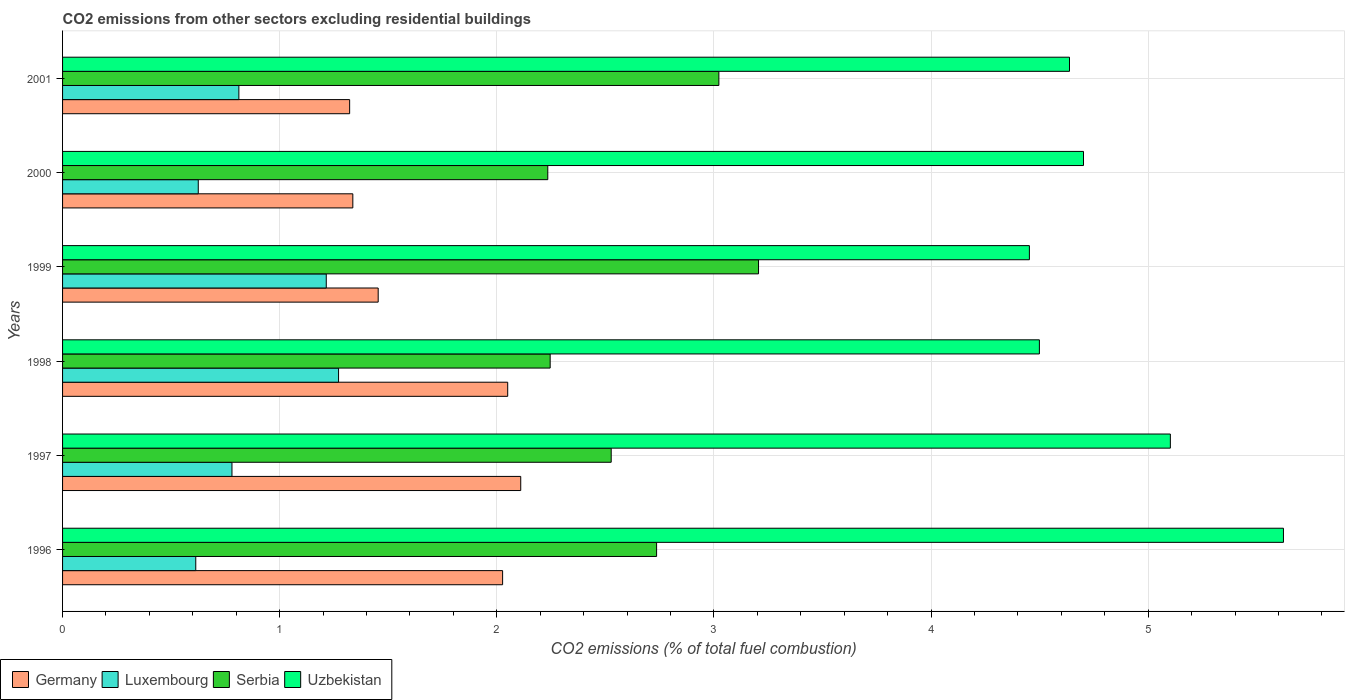How many different coloured bars are there?
Provide a succinct answer. 4. What is the label of the 5th group of bars from the top?
Offer a terse response. 1997. What is the total CO2 emitted in Luxembourg in 1999?
Your answer should be very brief. 1.21. Across all years, what is the maximum total CO2 emitted in Luxembourg?
Offer a very short reply. 1.27. Across all years, what is the minimum total CO2 emitted in Luxembourg?
Make the answer very short. 0.61. In which year was the total CO2 emitted in Uzbekistan minimum?
Keep it short and to the point. 1999. What is the total total CO2 emitted in Serbia in the graph?
Make the answer very short. 15.97. What is the difference between the total CO2 emitted in Serbia in 1999 and that in 2000?
Make the answer very short. 0.97. What is the difference between the total CO2 emitted in Germany in 2001 and the total CO2 emitted in Serbia in 1999?
Provide a short and direct response. -1.88. What is the average total CO2 emitted in Germany per year?
Ensure brevity in your answer.  1.72. In the year 1999, what is the difference between the total CO2 emitted in Germany and total CO2 emitted in Serbia?
Provide a short and direct response. -1.75. In how many years, is the total CO2 emitted in Serbia greater than 4.8 ?
Offer a very short reply. 0. What is the ratio of the total CO2 emitted in Germany in 1996 to that in 1998?
Offer a very short reply. 0.99. Is the total CO2 emitted in Serbia in 1997 less than that in 1998?
Your response must be concise. No. What is the difference between the highest and the second highest total CO2 emitted in Germany?
Provide a succinct answer. 0.06. What is the difference between the highest and the lowest total CO2 emitted in Uzbekistan?
Offer a terse response. 1.17. In how many years, is the total CO2 emitted in Germany greater than the average total CO2 emitted in Germany taken over all years?
Provide a succinct answer. 3. What does the 1st bar from the top in 2001 represents?
Offer a very short reply. Uzbekistan. What does the 1st bar from the bottom in 2001 represents?
Ensure brevity in your answer.  Germany. Is it the case that in every year, the sum of the total CO2 emitted in Germany and total CO2 emitted in Uzbekistan is greater than the total CO2 emitted in Serbia?
Make the answer very short. Yes. How many bars are there?
Provide a short and direct response. 24. How many years are there in the graph?
Your answer should be very brief. 6. Does the graph contain any zero values?
Provide a short and direct response. No. Does the graph contain grids?
Keep it short and to the point. Yes. Where does the legend appear in the graph?
Make the answer very short. Bottom left. How many legend labels are there?
Your answer should be very brief. 4. How are the legend labels stacked?
Your answer should be very brief. Horizontal. What is the title of the graph?
Offer a terse response. CO2 emissions from other sectors excluding residential buildings. What is the label or title of the X-axis?
Make the answer very short. CO2 emissions (% of total fuel combustion). What is the CO2 emissions (% of total fuel combustion) of Germany in 1996?
Make the answer very short. 2.03. What is the CO2 emissions (% of total fuel combustion) in Luxembourg in 1996?
Your answer should be very brief. 0.61. What is the CO2 emissions (% of total fuel combustion) in Serbia in 1996?
Ensure brevity in your answer.  2.74. What is the CO2 emissions (% of total fuel combustion) of Uzbekistan in 1996?
Your response must be concise. 5.62. What is the CO2 emissions (% of total fuel combustion) of Germany in 1997?
Your response must be concise. 2.11. What is the CO2 emissions (% of total fuel combustion) in Luxembourg in 1997?
Your answer should be compact. 0.78. What is the CO2 emissions (% of total fuel combustion) of Serbia in 1997?
Give a very brief answer. 2.53. What is the CO2 emissions (% of total fuel combustion) of Uzbekistan in 1997?
Make the answer very short. 5.1. What is the CO2 emissions (% of total fuel combustion) in Germany in 1998?
Keep it short and to the point. 2.05. What is the CO2 emissions (% of total fuel combustion) of Luxembourg in 1998?
Your answer should be very brief. 1.27. What is the CO2 emissions (% of total fuel combustion) of Serbia in 1998?
Provide a succinct answer. 2.25. What is the CO2 emissions (% of total fuel combustion) of Uzbekistan in 1998?
Your answer should be compact. 4.5. What is the CO2 emissions (% of total fuel combustion) in Germany in 1999?
Your answer should be very brief. 1.45. What is the CO2 emissions (% of total fuel combustion) in Luxembourg in 1999?
Keep it short and to the point. 1.21. What is the CO2 emissions (% of total fuel combustion) of Serbia in 1999?
Offer a very short reply. 3.21. What is the CO2 emissions (% of total fuel combustion) of Uzbekistan in 1999?
Keep it short and to the point. 4.45. What is the CO2 emissions (% of total fuel combustion) in Germany in 2000?
Give a very brief answer. 1.34. What is the CO2 emissions (% of total fuel combustion) of Luxembourg in 2000?
Keep it short and to the point. 0.62. What is the CO2 emissions (% of total fuel combustion) of Serbia in 2000?
Give a very brief answer. 2.23. What is the CO2 emissions (% of total fuel combustion) in Uzbekistan in 2000?
Provide a succinct answer. 4.7. What is the CO2 emissions (% of total fuel combustion) in Germany in 2001?
Offer a very short reply. 1.32. What is the CO2 emissions (% of total fuel combustion) in Luxembourg in 2001?
Offer a terse response. 0.81. What is the CO2 emissions (% of total fuel combustion) in Serbia in 2001?
Keep it short and to the point. 3.02. What is the CO2 emissions (% of total fuel combustion) of Uzbekistan in 2001?
Provide a succinct answer. 4.64. Across all years, what is the maximum CO2 emissions (% of total fuel combustion) in Germany?
Keep it short and to the point. 2.11. Across all years, what is the maximum CO2 emissions (% of total fuel combustion) in Luxembourg?
Ensure brevity in your answer.  1.27. Across all years, what is the maximum CO2 emissions (% of total fuel combustion) of Serbia?
Ensure brevity in your answer.  3.21. Across all years, what is the maximum CO2 emissions (% of total fuel combustion) of Uzbekistan?
Make the answer very short. 5.62. Across all years, what is the minimum CO2 emissions (% of total fuel combustion) of Germany?
Provide a short and direct response. 1.32. Across all years, what is the minimum CO2 emissions (% of total fuel combustion) in Luxembourg?
Keep it short and to the point. 0.61. Across all years, what is the minimum CO2 emissions (% of total fuel combustion) of Serbia?
Your response must be concise. 2.23. Across all years, what is the minimum CO2 emissions (% of total fuel combustion) in Uzbekistan?
Give a very brief answer. 4.45. What is the total CO2 emissions (% of total fuel combustion) in Luxembourg in the graph?
Offer a very short reply. 5.32. What is the total CO2 emissions (% of total fuel combustion) of Serbia in the graph?
Ensure brevity in your answer.  15.97. What is the total CO2 emissions (% of total fuel combustion) in Uzbekistan in the graph?
Ensure brevity in your answer.  29.02. What is the difference between the CO2 emissions (% of total fuel combustion) in Germany in 1996 and that in 1997?
Ensure brevity in your answer.  -0.08. What is the difference between the CO2 emissions (% of total fuel combustion) in Luxembourg in 1996 and that in 1997?
Make the answer very short. -0.17. What is the difference between the CO2 emissions (% of total fuel combustion) of Serbia in 1996 and that in 1997?
Keep it short and to the point. 0.21. What is the difference between the CO2 emissions (% of total fuel combustion) in Uzbekistan in 1996 and that in 1997?
Make the answer very short. 0.52. What is the difference between the CO2 emissions (% of total fuel combustion) in Germany in 1996 and that in 1998?
Make the answer very short. -0.02. What is the difference between the CO2 emissions (% of total fuel combustion) in Luxembourg in 1996 and that in 1998?
Your response must be concise. -0.66. What is the difference between the CO2 emissions (% of total fuel combustion) of Serbia in 1996 and that in 1998?
Provide a succinct answer. 0.49. What is the difference between the CO2 emissions (% of total fuel combustion) of Uzbekistan in 1996 and that in 1998?
Make the answer very short. 1.12. What is the difference between the CO2 emissions (% of total fuel combustion) of Germany in 1996 and that in 1999?
Offer a very short reply. 0.57. What is the difference between the CO2 emissions (% of total fuel combustion) of Luxembourg in 1996 and that in 1999?
Provide a short and direct response. -0.6. What is the difference between the CO2 emissions (% of total fuel combustion) of Serbia in 1996 and that in 1999?
Your answer should be compact. -0.47. What is the difference between the CO2 emissions (% of total fuel combustion) of Uzbekistan in 1996 and that in 1999?
Give a very brief answer. 1.17. What is the difference between the CO2 emissions (% of total fuel combustion) of Germany in 1996 and that in 2000?
Your answer should be compact. 0.69. What is the difference between the CO2 emissions (% of total fuel combustion) in Luxembourg in 1996 and that in 2000?
Ensure brevity in your answer.  -0.01. What is the difference between the CO2 emissions (% of total fuel combustion) in Serbia in 1996 and that in 2000?
Ensure brevity in your answer.  0.5. What is the difference between the CO2 emissions (% of total fuel combustion) in Uzbekistan in 1996 and that in 2000?
Your response must be concise. 0.92. What is the difference between the CO2 emissions (% of total fuel combustion) of Germany in 1996 and that in 2001?
Make the answer very short. 0.7. What is the difference between the CO2 emissions (% of total fuel combustion) of Luxembourg in 1996 and that in 2001?
Offer a very short reply. -0.2. What is the difference between the CO2 emissions (% of total fuel combustion) in Serbia in 1996 and that in 2001?
Your response must be concise. -0.29. What is the difference between the CO2 emissions (% of total fuel combustion) in Uzbekistan in 1996 and that in 2001?
Provide a succinct answer. 0.99. What is the difference between the CO2 emissions (% of total fuel combustion) of Germany in 1997 and that in 1998?
Provide a short and direct response. 0.06. What is the difference between the CO2 emissions (% of total fuel combustion) of Luxembourg in 1997 and that in 1998?
Offer a terse response. -0.49. What is the difference between the CO2 emissions (% of total fuel combustion) of Serbia in 1997 and that in 1998?
Provide a short and direct response. 0.28. What is the difference between the CO2 emissions (% of total fuel combustion) of Uzbekistan in 1997 and that in 1998?
Offer a terse response. 0.6. What is the difference between the CO2 emissions (% of total fuel combustion) in Germany in 1997 and that in 1999?
Your response must be concise. 0.66. What is the difference between the CO2 emissions (% of total fuel combustion) in Luxembourg in 1997 and that in 1999?
Provide a short and direct response. -0.43. What is the difference between the CO2 emissions (% of total fuel combustion) of Serbia in 1997 and that in 1999?
Ensure brevity in your answer.  -0.68. What is the difference between the CO2 emissions (% of total fuel combustion) of Uzbekistan in 1997 and that in 1999?
Give a very brief answer. 0.65. What is the difference between the CO2 emissions (% of total fuel combustion) in Germany in 1997 and that in 2000?
Ensure brevity in your answer.  0.77. What is the difference between the CO2 emissions (% of total fuel combustion) of Luxembourg in 1997 and that in 2000?
Provide a short and direct response. 0.16. What is the difference between the CO2 emissions (% of total fuel combustion) in Serbia in 1997 and that in 2000?
Make the answer very short. 0.29. What is the difference between the CO2 emissions (% of total fuel combustion) of Germany in 1997 and that in 2001?
Your answer should be very brief. 0.79. What is the difference between the CO2 emissions (% of total fuel combustion) in Luxembourg in 1997 and that in 2001?
Your answer should be compact. -0.03. What is the difference between the CO2 emissions (% of total fuel combustion) in Serbia in 1997 and that in 2001?
Your answer should be compact. -0.5. What is the difference between the CO2 emissions (% of total fuel combustion) in Uzbekistan in 1997 and that in 2001?
Offer a terse response. 0.46. What is the difference between the CO2 emissions (% of total fuel combustion) in Germany in 1998 and that in 1999?
Make the answer very short. 0.6. What is the difference between the CO2 emissions (% of total fuel combustion) in Luxembourg in 1998 and that in 1999?
Ensure brevity in your answer.  0.06. What is the difference between the CO2 emissions (% of total fuel combustion) of Serbia in 1998 and that in 1999?
Your answer should be very brief. -0.96. What is the difference between the CO2 emissions (% of total fuel combustion) of Uzbekistan in 1998 and that in 1999?
Offer a very short reply. 0.05. What is the difference between the CO2 emissions (% of total fuel combustion) of Germany in 1998 and that in 2000?
Keep it short and to the point. 0.71. What is the difference between the CO2 emissions (% of total fuel combustion) in Luxembourg in 1998 and that in 2000?
Provide a short and direct response. 0.65. What is the difference between the CO2 emissions (% of total fuel combustion) of Serbia in 1998 and that in 2000?
Your response must be concise. 0.01. What is the difference between the CO2 emissions (% of total fuel combustion) of Uzbekistan in 1998 and that in 2000?
Offer a terse response. -0.2. What is the difference between the CO2 emissions (% of total fuel combustion) in Germany in 1998 and that in 2001?
Your answer should be very brief. 0.73. What is the difference between the CO2 emissions (% of total fuel combustion) in Luxembourg in 1998 and that in 2001?
Make the answer very short. 0.46. What is the difference between the CO2 emissions (% of total fuel combustion) in Serbia in 1998 and that in 2001?
Offer a terse response. -0.78. What is the difference between the CO2 emissions (% of total fuel combustion) of Uzbekistan in 1998 and that in 2001?
Your answer should be compact. -0.14. What is the difference between the CO2 emissions (% of total fuel combustion) of Germany in 1999 and that in 2000?
Offer a terse response. 0.12. What is the difference between the CO2 emissions (% of total fuel combustion) of Luxembourg in 1999 and that in 2000?
Provide a short and direct response. 0.59. What is the difference between the CO2 emissions (% of total fuel combustion) of Serbia in 1999 and that in 2000?
Offer a very short reply. 0.97. What is the difference between the CO2 emissions (% of total fuel combustion) of Uzbekistan in 1999 and that in 2000?
Your answer should be compact. -0.25. What is the difference between the CO2 emissions (% of total fuel combustion) of Germany in 1999 and that in 2001?
Your answer should be compact. 0.13. What is the difference between the CO2 emissions (% of total fuel combustion) of Luxembourg in 1999 and that in 2001?
Ensure brevity in your answer.  0.4. What is the difference between the CO2 emissions (% of total fuel combustion) in Serbia in 1999 and that in 2001?
Ensure brevity in your answer.  0.18. What is the difference between the CO2 emissions (% of total fuel combustion) of Uzbekistan in 1999 and that in 2001?
Offer a very short reply. -0.18. What is the difference between the CO2 emissions (% of total fuel combustion) of Germany in 2000 and that in 2001?
Provide a succinct answer. 0.01. What is the difference between the CO2 emissions (% of total fuel combustion) in Luxembourg in 2000 and that in 2001?
Ensure brevity in your answer.  -0.19. What is the difference between the CO2 emissions (% of total fuel combustion) of Serbia in 2000 and that in 2001?
Make the answer very short. -0.79. What is the difference between the CO2 emissions (% of total fuel combustion) of Uzbekistan in 2000 and that in 2001?
Give a very brief answer. 0.06. What is the difference between the CO2 emissions (% of total fuel combustion) in Germany in 1996 and the CO2 emissions (% of total fuel combustion) in Luxembourg in 1997?
Make the answer very short. 1.25. What is the difference between the CO2 emissions (% of total fuel combustion) in Germany in 1996 and the CO2 emissions (% of total fuel combustion) in Serbia in 1997?
Give a very brief answer. -0.5. What is the difference between the CO2 emissions (% of total fuel combustion) in Germany in 1996 and the CO2 emissions (% of total fuel combustion) in Uzbekistan in 1997?
Your response must be concise. -3.08. What is the difference between the CO2 emissions (% of total fuel combustion) in Luxembourg in 1996 and the CO2 emissions (% of total fuel combustion) in Serbia in 1997?
Your answer should be compact. -1.91. What is the difference between the CO2 emissions (% of total fuel combustion) in Luxembourg in 1996 and the CO2 emissions (% of total fuel combustion) in Uzbekistan in 1997?
Your response must be concise. -4.49. What is the difference between the CO2 emissions (% of total fuel combustion) in Serbia in 1996 and the CO2 emissions (% of total fuel combustion) in Uzbekistan in 1997?
Make the answer very short. -2.37. What is the difference between the CO2 emissions (% of total fuel combustion) of Germany in 1996 and the CO2 emissions (% of total fuel combustion) of Luxembourg in 1998?
Your answer should be very brief. 0.76. What is the difference between the CO2 emissions (% of total fuel combustion) in Germany in 1996 and the CO2 emissions (% of total fuel combustion) in Serbia in 1998?
Provide a short and direct response. -0.22. What is the difference between the CO2 emissions (% of total fuel combustion) of Germany in 1996 and the CO2 emissions (% of total fuel combustion) of Uzbekistan in 1998?
Ensure brevity in your answer.  -2.47. What is the difference between the CO2 emissions (% of total fuel combustion) in Luxembourg in 1996 and the CO2 emissions (% of total fuel combustion) in Serbia in 1998?
Give a very brief answer. -1.63. What is the difference between the CO2 emissions (% of total fuel combustion) in Luxembourg in 1996 and the CO2 emissions (% of total fuel combustion) in Uzbekistan in 1998?
Your answer should be compact. -3.89. What is the difference between the CO2 emissions (% of total fuel combustion) of Serbia in 1996 and the CO2 emissions (% of total fuel combustion) of Uzbekistan in 1998?
Your answer should be compact. -1.76. What is the difference between the CO2 emissions (% of total fuel combustion) in Germany in 1996 and the CO2 emissions (% of total fuel combustion) in Luxembourg in 1999?
Keep it short and to the point. 0.81. What is the difference between the CO2 emissions (% of total fuel combustion) in Germany in 1996 and the CO2 emissions (% of total fuel combustion) in Serbia in 1999?
Provide a short and direct response. -1.18. What is the difference between the CO2 emissions (% of total fuel combustion) in Germany in 1996 and the CO2 emissions (% of total fuel combustion) in Uzbekistan in 1999?
Give a very brief answer. -2.43. What is the difference between the CO2 emissions (% of total fuel combustion) of Luxembourg in 1996 and the CO2 emissions (% of total fuel combustion) of Serbia in 1999?
Offer a terse response. -2.59. What is the difference between the CO2 emissions (% of total fuel combustion) in Luxembourg in 1996 and the CO2 emissions (% of total fuel combustion) in Uzbekistan in 1999?
Your answer should be very brief. -3.84. What is the difference between the CO2 emissions (% of total fuel combustion) in Serbia in 1996 and the CO2 emissions (% of total fuel combustion) in Uzbekistan in 1999?
Your response must be concise. -1.72. What is the difference between the CO2 emissions (% of total fuel combustion) of Germany in 1996 and the CO2 emissions (% of total fuel combustion) of Luxembourg in 2000?
Provide a short and direct response. 1.4. What is the difference between the CO2 emissions (% of total fuel combustion) of Germany in 1996 and the CO2 emissions (% of total fuel combustion) of Serbia in 2000?
Your response must be concise. -0.21. What is the difference between the CO2 emissions (% of total fuel combustion) of Germany in 1996 and the CO2 emissions (% of total fuel combustion) of Uzbekistan in 2000?
Offer a very short reply. -2.68. What is the difference between the CO2 emissions (% of total fuel combustion) in Luxembourg in 1996 and the CO2 emissions (% of total fuel combustion) in Serbia in 2000?
Ensure brevity in your answer.  -1.62. What is the difference between the CO2 emissions (% of total fuel combustion) in Luxembourg in 1996 and the CO2 emissions (% of total fuel combustion) in Uzbekistan in 2000?
Offer a very short reply. -4.09. What is the difference between the CO2 emissions (% of total fuel combustion) of Serbia in 1996 and the CO2 emissions (% of total fuel combustion) of Uzbekistan in 2000?
Keep it short and to the point. -1.97. What is the difference between the CO2 emissions (% of total fuel combustion) in Germany in 1996 and the CO2 emissions (% of total fuel combustion) in Luxembourg in 2001?
Give a very brief answer. 1.21. What is the difference between the CO2 emissions (% of total fuel combustion) in Germany in 1996 and the CO2 emissions (% of total fuel combustion) in Serbia in 2001?
Provide a succinct answer. -1. What is the difference between the CO2 emissions (% of total fuel combustion) of Germany in 1996 and the CO2 emissions (% of total fuel combustion) of Uzbekistan in 2001?
Give a very brief answer. -2.61. What is the difference between the CO2 emissions (% of total fuel combustion) of Luxembourg in 1996 and the CO2 emissions (% of total fuel combustion) of Serbia in 2001?
Provide a succinct answer. -2.41. What is the difference between the CO2 emissions (% of total fuel combustion) in Luxembourg in 1996 and the CO2 emissions (% of total fuel combustion) in Uzbekistan in 2001?
Offer a terse response. -4.02. What is the difference between the CO2 emissions (% of total fuel combustion) in Serbia in 1996 and the CO2 emissions (% of total fuel combustion) in Uzbekistan in 2001?
Give a very brief answer. -1.9. What is the difference between the CO2 emissions (% of total fuel combustion) of Germany in 1997 and the CO2 emissions (% of total fuel combustion) of Luxembourg in 1998?
Ensure brevity in your answer.  0.84. What is the difference between the CO2 emissions (% of total fuel combustion) in Germany in 1997 and the CO2 emissions (% of total fuel combustion) in Serbia in 1998?
Give a very brief answer. -0.14. What is the difference between the CO2 emissions (% of total fuel combustion) in Germany in 1997 and the CO2 emissions (% of total fuel combustion) in Uzbekistan in 1998?
Your answer should be compact. -2.39. What is the difference between the CO2 emissions (% of total fuel combustion) of Luxembourg in 1997 and the CO2 emissions (% of total fuel combustion) of Serbia in 1998?
Your answer should be very brief. -1.47. What is the difference between the CO2 emissions (% of total fuel combustion) of Luxembourg in 1997 and the CO2 emissions (% of total fuel combustion) of Uzbekistan in 1998?
Your response must be concise. -3.72. What is the difference between the CO2 emissions (% of total fuel combustion) in Serbia in 1997 and the CO2 emissions (% of total fuel combustion) in Uzbekistan in 1998?
Provide a short and direct response. -1.97. What is the difference between the CO2 emissions (% of total fuel combustion) in Germany in 1997 and the CO2 emissions (% of total fuel combustion) in Luxembourg in 1999?
Offer a terse response. 0.9. What is the difference between the CO2 emissions (% of total fuel combustion) of Germany in 1997 and the CO2 emissions (% of total fuel combustion) of Serbia in 1999?
Provide a succinct answer. -1.1. What is the difference between the CO2 emissions (% of total fuel combustion) of Germany in 1997 and the CO2 emissions (% of total fuel combustion) of Uzbekistan in 1999?
Offer a terse response. -2.34. What is the difference between the CO2 emissions (% of total fuel combustion) of Luxembourg in 1997 and the CO2 emissions (% of total fuel combustion) of Serbia in 1999?
Provide a short and direct response. -2.43. What is the difference between the CO2 emissions (% of total fuel combustion) in Luxembourg in 1997 and the CO2 emissions (% of total fuel combustion) in Uzbekistan in 1999?
Your response must be concise. -3.67. What is the difference between the CO2 emissions (% of total fuel combustion) of Serbia in 1997 and the CO2 emissions (% of total fuel combustion) of Uzbekistan in 1999?
Provide a short and direct response. -1.93. What is the difference between the CO2 emissions (% of total fuel combustion) in Germany in 1997 and the CO2 emissions (% of total fuel combustion) in Luxembourg in 2000?
Make the answer very short. 1.49. What is the difference between the CO2 emissions (% of total fuel combustion) of Germany in 1997 and the CO2 emissions (% of total fuel combustion) of Serbia in 2000?
Keep it short and to the point. -0.12. What is the difference between the CO2 emissions (% of total fuel combustion) of Germany in 1997 and the CO2 emissions (% of total fuel combustion) of Uzbekistan in 2000?
Give a very brief answer. -2.59. What is the difference between the CO2 emissions (% of total fuel combustion) in Luxembourg in 1997 and the CO2 emissions (% of total fuel combustion) in Serbia in 2000?
Ensure brevity in your answer.  -1.45. What is the difference between the CO2 emissions (% of total fuel combustion) of Luxembourg in 1997 and the CO2 emissions (% of total fuel combustion) of Uzbekistan in 2000?
Ensure brevity in your answer.  -3.92. What is the difference between the CO2 emissions (% of total fuel combustion) of Serbia in 1997 and the CO2 emissions (% of total fuel combustion) of Uzbekistan in 2000?
Your answer should be very brief. -2.18. What is the difference between the CO2 emissions (% of total fuel combustion) in Germany in 1997 and the CO2 emissions (% of total fuel combustion) in Luxembourg in 2001?
Provide a short and direct response. 1.3. What is the difference between the CO2 emissions (% of total fuel combustion) in Germany in 1997 and the CO2 emissions (% of total fuel combustion) in Serbia in 2001?
Ensure brevity in your answer.  -0.91. What is the difference between the CO2 emissions (% of total fuel combustion) of Germany in 1997 and the CO2 emissions (% of total fuel combustion) of Uzbekistan in 2001?
Keep it short and to the point. -2.53. What is the difference between the CO2 emissions (% of total fuel combustion) in Luxembourg in 1997 and the CO2 emissions (% of total fuel combustion) in Serbia in 2001?
Offer a very short reply. -2.24. What is the difference between the CO2 emissions (% of total fuel combustion) in Luxembourg in 1997 and the CO2 emissions (% of total fuel combustion) in Uzbekistan in 2001?
Give a very brief answer. -3.86. What is the difference between the CO2 emissions (% of total fuel combustion) in Serbia in 1997 and the CO2 emissions (% of total fuel combustion) in Uzbekistan in 2001?
Offer a terse response. -2.11. What is the difference between the CO2 emissions (% of total fuel combustion) of Germany in 1998 and the CO2 emissions (% of total fuel combustion) of Luxembourg in 1999?
Offer a terse response. 0.84. What is the difference between the CO2 emissions (% of total fuel combustion) of Germany in 1998 and the CO2 emissions (% of total fuel combustion) of Serbia in 1999?
Provide a succinct answer. -1.16. What is the difference between the CO2 emissions (% of total fuel combustion) in Germany in 1998 and the CO2 emissions (% of total fuel combustion) in Uzbekistan in 1999?
Give a very brief answer. -2.4. What is the difference between the CO2 emissions (% of total fuel combustion) of Luxembourg in 1998 and the CO2 emissions (% of total fuel combustion) of Serbia in 1999?
Make the answer very short. -1.93. What is the difference between the CO2 emissions (% of total fuel combustion) of Luxembourg in 1998 and the CO2 emissions (% of total fuel combustion) of Uzbekistan in 1999?
Make the answer very short. -3.18. What is the difference between the CO2 emissions (% of total fuel combustion) in Serbia in 1998 and the CO2 emissions (% of total fuel combustion) in Uzbekistan in 1999?
Your answer should be compact. -2.21. What is the difference between the CO2 emissions (% of total fuel combustion) in Germany in 1998 and the CO2 emissions (% of total fuel combustion) in Luxembourg in 2000?
Provide a succinct answer. 1.43. What is the difference between the CO2 emissions (% of total fuel combustion) of Germany in 1998 and the CO2 emissions (% of total fuel combustion) of Serbia in 2000?
Your response must be concise. -0.18. What is the difference between the CO2 emissions (% of total fuel combustion) in Germany in 1998 and the CO2 emissions (% of total fuel combustion) in Uzbekistan in 2000?
Your response must be concise. -2.65. What is the difference between the CO2 emissions (% of total fuel combustion) in Luxembourg in 1998 and the CO2 emissions (% of total fuel combustion) in Serbia in 2000?
Give a very brief answer. -0.96. What is the difference between the CO2 emissions (% of total fuel combustion) in Luxembourg in 1998 and the CO2 emissions (% of total fuel combustion) in Uzbekistan in 2000?
Your answer should be compact. -3.43. What is the difference between the CO2 emissions (% of total fuel combustion) in Serbia in 1998 and the CO2 emissions (% of total fuel combustion) in Uzbekistan in 2000?
Your answer should be compact. -2.46. What is the difference between the CO2 emissions (% of total fuel combustion) of Germany in 1998 and the CO2 emissions (% of total fuel combustion) of Luxembourg in 2001?
Offer a terse response. 1.24. What is the difference between the CO2 emissions (% of total fuel combustion) in Germany in 1998 and the CO2 emissions (% of total fuel combustion) in Serbia in 2001?
Ensure brevity in your answer.  -0.97. What is the difference between the CO2 emissions (% of total fuel combustion) in Germany in 1998 and the CO2 emissions (% of total fuel combustion) in Uzbekistan in 2001?
Your answer should be compact. -2.59. What is the difference between the CO2 emissions (% of total fuel combustion) of Luxembourg in 1998 and the CO2 emissions (% of total fuel combustion) of Serbia in 2001?
Offer a very short reply. -1.75. What is the difference between the CO2 emissions (% of total fuel combustion) of Luxembourg in 1998 and the CO2 emissions (% of total fuel combustion) of Uzbekistan in 2001?
Ensure brevity in your answer.  -3.37. What is the difference between the CO2 emissions (% of total fuel combustion) of Serbia in 1998 and the CO2 emissions (% of total fuel combustion) of Uzbekistan in 2001?
Your response must be concise. -2.39. What is the difference between the CO2 emissions (% of total fuel combustion) of Germany in 1999 and the CO2 emissions (% of total fuel combustion) of Luxembourg in 2000?
Ensure brevity in your answer.  0.83. What is the difference between the CO2 emissions (% of total fuel combustion) of Germany in 1999 and the CO2 emissions (% of total fuel combustion) of Serbia in 2000?
Your answer should be very brief. -0.78. What is the difference between the CO2 emissions (% of total fuel combustion) of Germany in 1999 and the CO2 emissions (% of total fuel combustion) of Uzbekistan in 2000?
Offer a terse response. -3.25. What is the difference between the CO2 emissions (% of total fuel combustion) of Luxembourg in 1999 and the CO2 emissions (% of total fuel combustion) of Serbia in 2000?
Your answer should be compact. -1.02. What is the difference between the CO2 emissions (% of total fuel combustion) in Luxembourg in 1999 and the CO2 emissions (% of total fuel combustion) in Uzbekistan in 2000?
Give a very brief answer. -3.49. What is the difference between the CO2 emissions (% of total fuel combustion) in Serbia in 1999 and the CO2 emissions (% of total fuel combustion) in Uzbekistan in 2000?
Your response must be concise. -1.5. What is the difference between the CO2 emissions (% of total fuel combustion) in Germany in 1999 and the CO2 emissions (% of total fuel combustion) in Luxembourg in 2001?
Provide a short and direct response. 0.64. What is the difference between the CO2 emissions (% of total fuel combustion) in Germany in 1999 and the CO2 emissions (% of total fuel combustion) in Serbia in 2001?
Your answer should be compact. -1.57. What is the difference between the CO2 emissions (% of total fuel combustion) of Germany in 1999 and the CO2 emissions (% of total fuel combustion) of Uzbekistan in 2001?
Make the answer very short. -3.18. What is the difference between the CO2 emissions (% of total fuel combustion) of Luxembourg in 1999 and the CO2 emissions (% of total fuel combustion) of Serbia in 2001?
Offer a very short reply. -1.81. What is the difference between the CO2 emissions (% of total fuel combustion) of Luxembourg in 1999 and the CO2 emissions (% of total fuel combustion) of Uzbekistan in 2001?
Your response must be concise. -3.42. What is the difference between the CO2 emissions (% of total fuel combustion) in Serbia in 1999 and the CO2 emissions (% of total fuel combustion) in Uzbekistan in 2001?
Your answer should be compact. -1.43. What is the difference between the CO2 emissions (% of total fuel combustion) in Germany in 2000 and the CO2 emissions (% of total fuel combustion) in Luxembourg in 2001?
Your response must be concise. 0.52. What is the difference between the CO2 emissions (% of total fuel combustion) of Germany in 2000 and the CO2 emissions (% of total fuel combustion) of Serbia in 2001?
Offer a terse response. -1.69. What is the difference between the CO2 emissions (% of total fuel combustion) of Germany in 2000 and the CO2 emissions (% of total fuel combustion) of Uzbekistan in 2001?
Your answer should be compact. -3.3. What is the difference between the CO2 emissions (% of total fuel combustion) in Luxembourg in 2000 and the CO2 emissions (% of total fuel combustion) in Serbia in 2001?
Make the answer very short. -2.4. What is the difference between the CO2 emissions (% of total fuel combustion) in Luxembourg in 2000 and the CO2 emissions (% of total fuel combustion) in Uzbekistan in 2001?
Your answer should be compact. -4.01. What is the difference between the CO2 emissions (% of total fuel combustion) in Serbia in 2000 and the CO2 emissions (% of total fuel combustion) in Uzbekistan in 2001?
Your response must be concise. -2.4. What is the average CO2 emissions (% of total fuel combustion) of Germany per year?
Your answer should be compact. 1.72. What is the average CO2 emissions (% of total fuel combustion) of Luxembourg per year?
Your response must be concise. 0.89. What is the average CO2 emissions (% of total fuel combustion) in Serbia per year?
Keep it short and to the point. 2.66. What is the average CO2 emissions (% of total fuel combustion) of Uzbekistan per year?
Keep it short and to the point. 4.84. In the year 1996, what is the difference between the CO2 emissions (% of total fuel combustion) in Germany and CO2 emissions (% of total fuel combustion) in Luxembourg?
Ensure brevity in your answer.  1.41. In the year 1996, what is the difference between the CO2 emissions (% of total fuel combustion) of Germany and CO2 emissions (% of total fuel combustion) of Serbia?
Give a very brief answer. -0.71. In the year 1996, what is the difference between the CO2 emissions (% of total fuel combustion) in Germany and CO2 emissions (% of total fuel combustion) in Uzbekistan?
Your response must be concise. -3.6. In the year 1996, what is the difference between the CO2 emissions (% of total fuel combustion) of Luxembourg and CO2 emissions (% of total fuel combustion) of Serbia?
Your response must be concise. -2.12. In the year 1996, what is the difference between the CO2 emissions (% of total fuel combustion) in Luxembourg and CO2 emissions (% of total fuel combustion) in Uzbekistan?
Your answer should be very brief. -5.01. In the year 1996, what is the difference between the CO2 emissions (% of total fuel combustion) of Serbia and CO2 emissions (% of total fuel combustion) of Uzbekistan?
Offer a very short reply. -2.89. In the year 1997, what is the difference between the CO2 emissions (% of total fuel combustion) of Germany and CO2 emissions (% of total fuel combustion) of Luxembourg?
Give a very brief answer. 1.33. In the year 1997, what is the difference between the CO2 emissions (% of total fuel combustion) in Germany and CO2 emissions (% of total fuel combustion) in Serbia?
Provide a short and direct response. -0.42. In the year 1997, what is the difference between the CO2 emissions (% of total fuel combustion) of Germany and CO2 emissions (% of total fuel combustion) of Uzbekistan?
Keep it short and to the point. -2.99. In the year 1997, what is the difference between the CO2 emissions (% of total fuel combustion) of Luxembourg and CO2 emissions (% of total fuel combustion) of Serbia?
Provide a short and direct response. -1.75. In the year 1997, what is the difference between the CO2 emissions (% of total fuel combustion) of Luxembourg and CO2 emissions (% of total fuel combustion) of Uzbekistan?
Keep it short and to the point. -4.32. In the year 1997, what is the difference between the CO2 emissions (% of total fuel combustion) of Serbia and CO2 emissions (% of total fuel combustion) of Uzbekistan?
Offer a terse response. -2.58. In the year 1998, what is the difference between the CO2 emissions (% of total fuel combustion) of Germany and CO2 emissions (% of total fuel combustion) of Luxembourg?
Ensure brevity in your answer.  0.78. In the year 1998, what is the difference between the CO2 emissions (% of total fuel combustion) in Germany and CO2 emissions (% of total fuel combustion) in Serbia?
Ensure brevity in your answer.  -0.2. In the year 1998, what is the difference between the CO2 emissions (% of total fuel combustion) in Germany and CO2 emissions (% of total fuel combustion) in Uzbekistan?
Keep it short and to the point. -2.45. In the year 1998, what is the difference between the CO2 emissions (% of total fuel combustion) of Luxembourg and CO2 emissions (% of total fuel combustion) of Serbia?
Your answer should be compact. -0.97. In the year 1998, what is the difference between the CO2 emissions (% of total fuel combustion) of Luxembourg and CO2 emissions (% of total fuel combustion) of Uzbekistan?
Ensure brevity in your answer.  -3.23. In the year 1998, what is the difference between the CO2 emissions (% of total fuel combustion) in Serbia and CO2 emissions (% of total fuel combustion) in Uzbekistan?
Offer a very short reply. -2.25. In the year 1999, what is the difference between the CO2 emissions (% of total fuel combustion) in Germany and CO2 emissions (% of total fuel combustion) in Luxembourg?
Your answer should be very brief. 0.24. In the year 1999, what is the difference between the CO2 emissions (% of total fuel combustion) of Germany and CO2 emissions (% of total fuel combustion) of Serbia?
Provide a succinct answer. -1.75. In the year 1999, what is the difference between the CO2 emissions (% of total fuel combustion) in Germany and CO2 emissions (% of total fuel combustion) in Uzbekistan?
Provide a short and direct response. -3. In the year 1999, what is the difference between the CO2 emissions (% of total fuel combustion) of Luxembourg and CO2 emissions (% of total fuel combustion) of Serbia?
Make the answer very short. -1.99. In the year 1999, what is the difference between the CO2 emissions (% of total fuel combustion) in Luxembourg and CO2 emissions (% of total fuel combustion) in Uzbekistan?
Keep it short and to the point. -3.24. In the year 1999, what is the difference between the CO2 emissions (% of total fuel combustion) of Serbia and CO2 emissions (% of total fuel combustion) of Uzbekistan?
Your answer should be compact. -1.25. In the year 2000, what is the difference between the CO2 emissions (% of total fuel combustion) of Germany and CO2 emissions (% of total fuel combustion) of Luxembourg?
Your answer should be very brief. 0.71. In the year 2000, what is the difference between the CO2 emissions (% of total fuel combustion) of Germany and CO2 emissions (% of total fuel combustion) of Serbia?
Your answer should be very brief. -0.9. In the year 2000, what is the difference between the CO2 emissions (% of total fuel combustion) in Germany and CO2 emissions (% of total fuel combustion) in Uzbekistan?
Offer a terse response. -3.37. In the year 2000, what is the difference between the CO2 emissions (% of total fuel combustion) in Luxembourg and CO2 emissions (% of total fuel combustion) in Serbia?
Offer a terse response. -1.61. In the year 2000, what is the difference between the CO2 emissions (% of total fuel combustion) in Luxembourg and CO2 emissions (% of total fuel combustion) in Uzbekistan?
Offer a very short reply. -4.08. In the year 2000, what is the difference between the CO2 emissions (% of total fuel combustion) of Serbia and CO2 emissions (% of total fuel combustion) of Uzbekistan?
Your response must be concise. -2.47. In the year 2001, what is the difference between the CO2 emissions (% of total fuel combustion) in Germany and CO2 emissions (% of total fuel combustion) in Luxembourg?
Provide a short and direct response. 0.51. In the year 2001, what is the difference between the CO2 emissions (% of total fuel combustion) of Germany and CO2 emissions (% of total fuel combustion) of Serbia?
Offer a terse response. -1.7. In the year 2001, what is the difference between the CO2 emissions (% of total fuel combustion) of Germany and CO2 emissions (% of total fuel combustion) of Uzbekistan?
Your answer should be compact. -3.32. In the year 2001, what is the difference between the CO2 emissions (% of total fuel combustion) of Luxembourg and CO2 emissions (% of total fuel combustion) of Serbia?
Provide a short and direct response. -2.21. In the year 2001, what is the difference between the CO2 emissions (% of total fuel combustion) of Luxembourg and CO2 emissions (% of total fuel combustion) of Uzbekistan?
Provide a succinct answer. -3.83. In the year 2001, what is the difference between the CO2 emissions (% of total fuel combustion) of Serbia and CO2 emissions (% of total fuel combustion) of Uzbekistan?
Your response must be concise. -1.61. What is the ratio of the CO2 emissions (% of total fuel combustion) in Germany in 1996 to that in 1997?
Give a very brief answer. 0.96. What is the ratio of the CO2 emissions (% of total fuel combustion) of Luxembourg in 1996 to that in 1997?
Offer a terse response. 0.79. What is the ratio of the CO2 emissions (% of total fuel combustion) in Serbia in 1996 to that in 1997?
Your answer should be compact. 1.08. What is the ratio of the CO2 emissions (% of total fuel combustion) in Uzbekistan in 1996 to that in 1997?
Your answer should be compact. 1.1. What is the ratio of the CO2 emissions (% of total fuel combustion) in Luxembourg in 1996 to that in 1998?
Ensure brevity in your answer.  0.48. What is the ratio of the CO2 emissions (% of total fuel combustion) of Serbia in 1996 to that in 1998?
Make the answer very short. 1.22. What is the ratio of the CO2 emissions (% of total fuel combustion) in Uzbekistan in 1996 to that in 1998?
Provide a short and direct response. 1.25. What is the ratio of the CO2 emissions (% of total fuel combustion) of Germany in 1996 to that in 1999?
Your answer should be compact. 1.39. What is the ratio of the CO2 emissions (% of total fuel combustion) in Luxembourg in 1996 to that in 1999?
Provide a succinct answer. 0.51. What is the ratio of the CO2 emissions (% of total fuel combustion) of Serbia in 1996 to that in 1999?
Provide a succinct answer. 0.85. What is the ratio of the CO2 emissions (% of total fuel combustion) in Uzbekistan in 1996 to that in 1999?
Provide a succinct answer. 1.26. What is the ratio of the CO2 emissions (% of total fuel combustion) in Germany in 1996 to that in 2000?
Your answer should be very brief. 1.52. What is the ratio of the CO2 emissions (% of total fuel combustion) in Luxembourg in 1996 to that in 2000?
Give a very brief answer. 0.98. What is the ratio of the CO2 emissions (% of total fuel combustion) in Serbia in 1996 to that in 2000?
Give a very brief answer. 1.22. What is the ratio of the CO2 emissions (% of total fuel combustion) of Uzbekistan in 1996 to that in 2000?
Keep it short and to the point. 1.2. What is the ratio of the CO2 emissions (% of total fuel combustion) of Germany in 1996 to that in 2001?
Ensure brevity in your answer.  1.53. What is the ratio of the CO2 emissions (% of total fuel combustion) in Luxembourg in 1996 to that in 2001?
Offer a terse response. 0.76. What is the ratio of the CO2 emissions (% of total fuel combustion) in Serbia in 1996 to that in 2001?
Offer a very short reply. 0.91. What is the ratio of the CO2 emissions (% of total fuel combustion) of Uzbekistan in 1996 to that in 2001?
Ensure brevity in your answer.  1.21. What is the ratio of the CO2 emissions (% of total fuel combustion) of Germany in 1997 to that in 1998?
Provide a short and direct response. 1.03. What is the ratio of the CO2 emissions (% of total fuel combustion) in Luxembourg in 1997 to that in 1998?
Your answer should be compact. 0.61. What is the ratio of the CO2 emissions (% of total fuel combustion) of Serbia in 1997 to that in 1998?
Provide a short and direct response. 1.13. What is the ratio of the CO2 emissions (% of total fuel combustion) in Uzbekistan in 1997 to that in 1998?
Offer a very short reply. 1.13. What is the ratio of the CO2 emissions (% of total fuel combustion) in Germany in 1997 to that in 1999?
Your answer should be very brief. 1.45. What is the ratio of the CO2 emissions (% of total fuel combustion) of Luxembourg in 1997 to that in 1999?
Offer a very short reply. 0.64. What is the ratio of the CO2 emissions (% of total fuel combustion) in Serbia in 1997 to that in 1999?
Give a very brief answer. 0.79. What is the ratio of the CO2 emissions (% of total fuel combustion) of Uzbekistan in 1997 to that in 1999?
Your response must be concise. 1.15. What is the ratio of the CO2 emissions (% of total fuel combustion) of Germany in 1997 to that in 2000?
Ensure brevity in your answer.  1.58. What is the ratio of the CO2 emissions (% of total fuel combustion) of Luxembourg in 1997 to that in 2000?
Ensure brevity in your answer.  1.25. What is the ratio of the CO2 emissions (% of total fuel combustion) of Serbia in 1997 to that in 2000?
Offer a very short reply. 1.13. What is the ratio of the CO2 emissions (% of total fuel combustion) in Uzbekistan in 1997 to that in 2000?
Ensure brevity in your answer.  1.09. What is the ratio of the CO2 emissions (% of total fuel combustion) of Germany in 1997 to that in 2001?
Provide a short and direct response. 1.6. What is the ratio of the CO2 emissions (% of total fuel combustion) of Luxembourg in 1997 to that in 2001?
Make the answer very short. 0.96. What is the ratio of the CO2 emissions (% of total fuel combustion) of Serbia in 1997 to that in 2001?
Make the answer very short. 0.84. What is the ratio of the CO2 emissions (% of total fuel combustion) in Uzbekistan in 1997 to that in 2001?
Keep it short and to the point. 1.1. What is the ratio of the CO2 emissions (% of total fuel combustion) of Germany in 1998 to that in 1999?
Your answer should be compact. 1.41. What is the ratio of the CO2 emissions (% of total fuel combustion) in Luxembourg in 1998 to that in 1999?
Your answer should be very brief. 1.05. What is the ratio of the CO2 emissions (% of total fuel combustion) of Serbia in 1998 to that in 1999?
Ensure brevity in your answer.  0.7. What is the ratio of the CO2 emissions (% of total fuel combustion) of Uzbekistan in 1998 to that in 1999?
Your answer should be very brief. 1.01. What is the ratio of the CO2 emissions (% of total fuel combustion) in Germany in 1998 to that in 2000?
Make the answer very short. 1.53. What is the ratio of the CO2 emissions (% of total fuel combustion) in Luxembourg in 1998 to that in 2000?
Provide a succinct answer. 2.03. What is the ratio of the CO2 emissions (% of total fuel combustion) of Uzbekistan in 1998 to that in 2000?
Your answer should be compact. 0.96. What is the ratio of the CO2 emissions (% of total fuel combustion) in Germany in 1998 to that in 2001?
Your answer should be very brief. 1.55. What is the ratio of the CO2 emissions (% of total fuel combustion) of Luxembourg in 1998 to that in 2001?
Provide a succinct answer. 1.57. What is the ratio of the CO2 emissions (% of total fuel combustion) in Serbia in 1998 to that in 2001?
Your answer should be compact. 0.74. What is the ratio of the CO2 emissions (% of total fuel combustion) of Uzbekistan in 1998 to that in 2001?
Keep it short and to the point. 0.97. What is the ratio of the CO2 emissions (% of total fuel combustion) in Germany in 1999 to that in 2000?
Your answer should be very brief. 1.09. What is the ratio of the CO2 emissions (% of total fuel combustion) of Luxembourg in 1999 to that in 2000?
Offer a terse response. 1.94. What is the ratio of the CO2 emissions (% of total fuel combustion) of Serbia in 1999 to that in 2000?
Offer a very short reply. 1.43. What is the ratio of the CO2 emissions (% of total fuel combustion) in Uzbekistan in 1999 to that in 2000?
Ensure brevity in your answer.  0.95. What is the ratio of the CO2 emissions (% of total fuel combustion) in Germany in 1999 to that in 2001?
Your answer should be compact. 1.1. What is the ratio of the CO2 emissions (% of total fuel combustion) in Luxembourg in 1999 to that in 2001?
Your response must be concise. 1.5. What is the ratio of the CO2 emissions (% of total fuel combustion) in Serbia in 1999 to that in 2001?
Provide a succinct answer. 1.06. What is the ratio of the CO2 emissions (% of total fuel combustion) of Uzbekistan in 1999 to that in 2001?
Give a very brief answer. 0.96. What is the ratio of the CO2 emissions (% of total fuel combustion) of Germany in 2000 to that in 2001?
Offer a very short reply. 1.01. What is the ratio of the CO2 emissions (% of total fuel combustion) in Luxembourg in 2000 to that in 2001?
Offer a terse response. 0.77. What is the ratio of the CO2 emissions (% of total fuel combustion) of Serbia in 2000 to that in 2001?
Your answer should be very brief. 0.74. What is the ratio of the CO2 emissions (% of total fuel combustion) in Uzbekistan in 2000 to that in 2001?
Keep it short and to the point. 1.01. What is the difference between the highest and the second highest CO2 emissions (% of total fuel combustion) in Luxembourg?
Your answer should be very brief. 0.06. What is the difference between the highest and the second highest CO2 emissions (% of total fuel combustion) of Serbia?
Keep it short and to the point. 0.18. What is the difference between the highest and the second highest CO2 emissions (% of total fuel combustion) in Uzbekistan?
Provide a short and direct response. 0.52. What is the difference between the highest and the lowest CO2 emissions (% of total fuel combustion) of Germany?
Keep it short and to the point. 0.79. What is the difference between the highest and the lowest CO2 emissions (% of total fuel combustion) in Luxembourg?
Your answer should be very brief. 0.66. What is the difference between the highest and the lowest CO2 emissions (% of total fuel combustion) in Serbia?
Provide a short and direct response. 0.97. What is the difference between the highest and the lowest CO2 emissions (% of total fuel combustion) of Uzbekistan?
Provide a short and direct response. 1.17. 